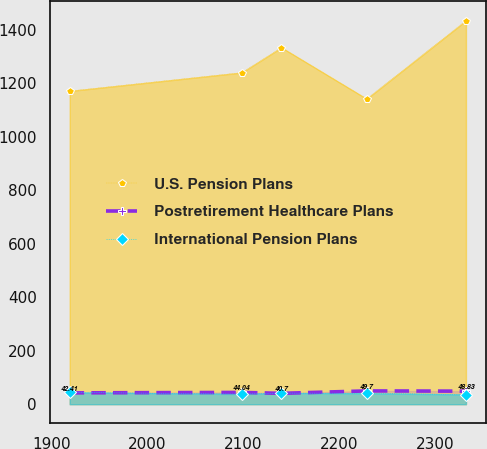<chart> <loc_0><loc_0><loc_500><loc_500><line_chart><ecel><fcel>U.S. Pension Plans<fcel>Postretirement Healthcare Plans<fcel>International Pension Plans<nl><fcel>1919.32<fcel>1170.36<fcel>42.41<fcel>44.08<nl><fcel>2098.66<fcel>1239.31<fcel>44.04<fcel>37.9<nl><fcel>2139.95<fcel>1332.87<fcel>40.7<fcel>41.53<nl><fcel>2228.79<fcel>1141.14<fcel>49.7<fcel>40.73<nl><fcel>2332.23<fcel>1433.37<fcel>48.83<fcel>36.09<nl></chart> 